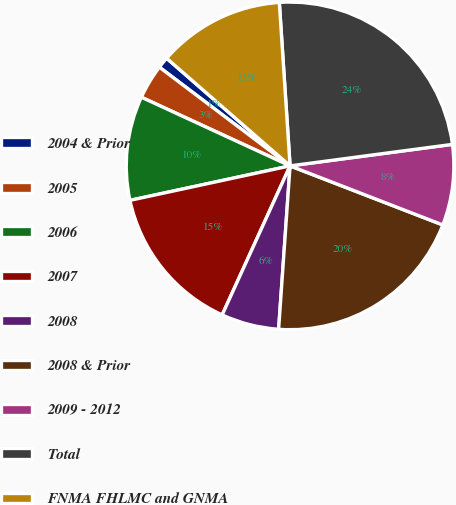Convert chart. <chart><loc_0><loc_0><loc_500><loc_500><pie_chart><fcel>2004 & Prior<fcel>2005<fcel>2006<fcel>2007<fcel>2008<fcel>2008 & Prior<fcel>2009 - 2012<fcel>Total<fcel>FNMA FHLMC and GNMA<nl><fcel>1.12%<fcel>3.41%<fcel>10.26%<fcel>14.82%<fcel>5.69%<fcel>20.24%<fcel>7.97%<fcel>23.95%<fcel>12.54%<nl></chart> 